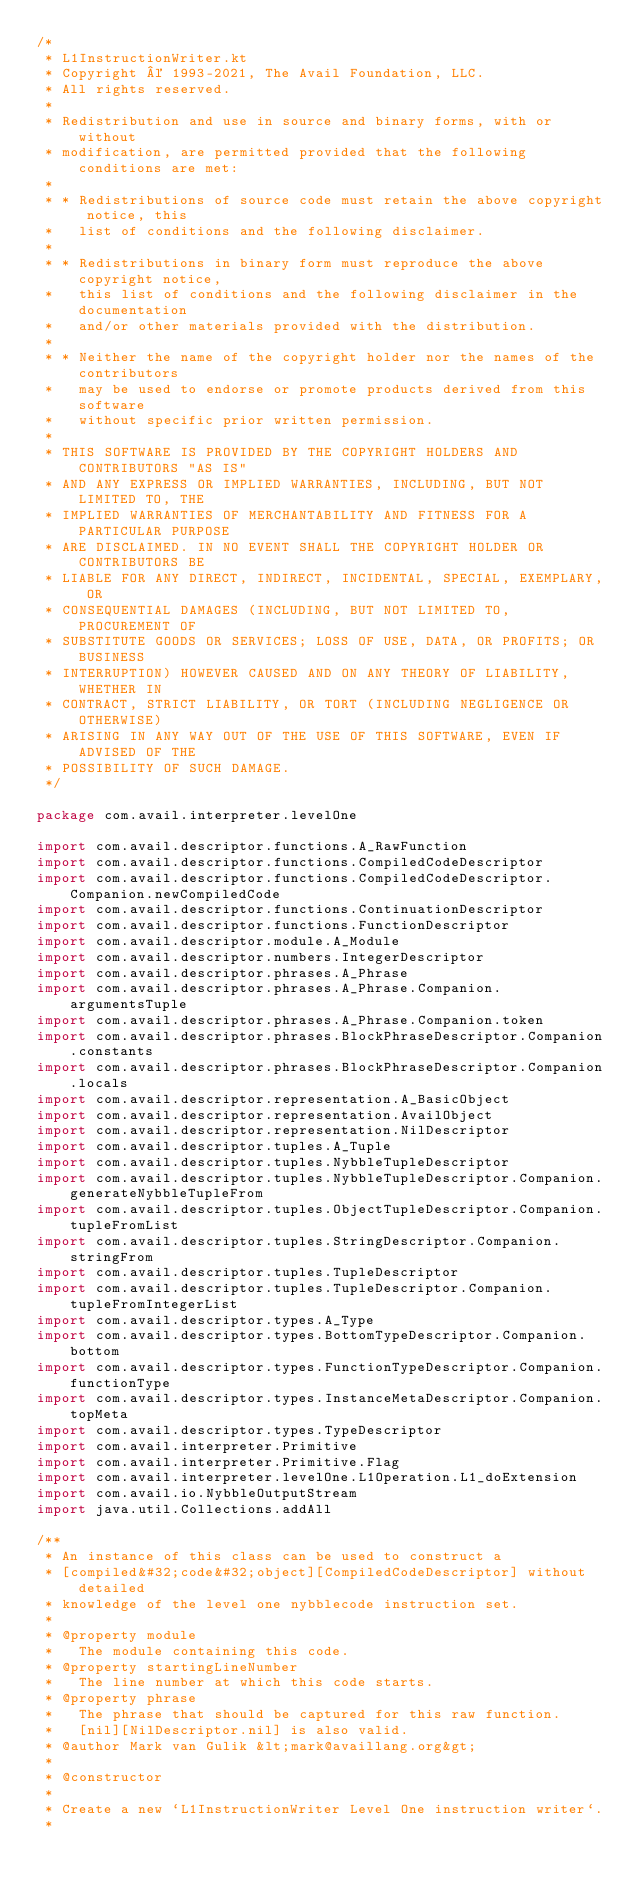<code> <loc_0><loc_0><loc_500><loc_500><_Kotlin_>/*
 * L1InstructionWriter.kt
 * Copyright © 1993-2021, The Avail Foundation, LLC.
 * All rights reserved.
 *
 * Redistribution and use in source and binary forms, with or without
 * modification, are permitted provided that the following conditions are met:
 *
 * * Redistributions of source code must retain the above copyright notice, this
 *   list of conditions and the following disclaimer.
 *
 * * Redistributions in binary form must reproduce the above copyright notice,
 *   this list of conditions and the following disclaimer in the documentation
 *   and/or other materials provided with the distribution.
 *
 * * Neither the name of the copyright holder nor the names of the contributors
 *   may be used to endorse or promote products derived from this software
 *   without specific prior written permission.
 *
 * THIS SOFTWARE IS PROVIDED BY THE COPYRIGHT HOLDERS AND CONTRIBUTORS "AS IS"
 * AND ANY EXPRESS OR IMPLIED WARRANTIES, INCLUDING, BUT NOT LIMITED TO, THE
 * IMPLIED WARRANTIES OF MERCHANTABILITY AND FITNESS FOR A PARTICULAR PURPOSE
 * ARE DISCLAIMED. IN NO EVENT SHALL THE COPYRIGHT HOLDER OR CONTRIBUTORS BE
 * LIABLE FOR ANY DIRECT, INDIRECT, INCIDENTAL, SPECIAL, EXEMPLARY, OR
 * CONSEQUENTIAL DAMAGES (INCLUDING, BUT NOT LIMITED TO, PROCUREMENT OF
 * SUBSTITUTE GOODS OR SERVICES; LOSS OF USE, DATA, OR PROFITS; OR BUSINESS
 * INTERRUPTION) HOWEVER CAUSED AND ON ANY THEORY OF LIABILITY, WHETHER IN
 * CONTRACT, STRICT LIABILITY, OR TORT (INCLUDING NEGLIGENCE OR OTHERWISE)
 * ARISING IN ANY WAY OUT OF THE USE OF THIS SOFTWARE, EVEN IF ADVISED OF THE
 * POSSIBILITY OF SUCH DAMAGE.
 */

package com.avail.interpreter.levelOne

import com.avail.descriptor.functions.A_RawFunction
import com.avail.descriptor.functions.CompiledCodeDescriptor
import com.avail.descriptor.functions.CompiledCodeDescriptor.Companion.newCompiledCode
import com.avail.descriptor.functions.ContinuationDescriptor
import com.avail.descriptor.functions.FunctionDescriptor
import com.avail.descriptor.module.A_Module
import com.avail.descriptor.numbers.IntegerDescriptor
import com.avail.descriptor.phrases.A_Phrase
import com.avail.descriptor.phrases.A_Phrase.Companion.argumentsTuple
import com.avail.descriptor.phrases.A_Phrase.Companion.token
import com.avail.descriptor.phrases.BlockPhraseDescriptor.Companion.constants
import com.avail.descriptor.phrases.BlockPhraseDescriptor.Companion.locals
import com.avail.descriptor.representation.A_BasicObject
import com.avail.descriptor.representation.AvailObject
import com.avail.descriptor.representation.NilDescriptor
import com.avail.descriptor.tuples.A_Tuple
import com.avail.descriptor.tuples.NybbleTupleDescriptor
import com.avail.descriptor.tuples.NybbleTupleDescriptor.Companion.generateNybbleTupleFrom
import com.avail.descriptor.tuples.ObjectTupleDescriptor.Companion.tupleFromList
import com.avail.descriptor.tuples.StringDescriptor.Companion.stringFrom
import com.avail.descriptor.tuples.TupleDescriptor
import com.avail.descriptor.tuples.TupleDescriptor.Companion.tupleFromIntegerList
import com.avail.descriptor.types.A_Type
import com.avail.descriptor.types.BottomTypeDescriptor.Companion.bottom
import com.avail.descriptor.types.FunctionTypeDescriptor.Companion.functionType
import com.avail.descriptor.types.InstanceMetaDescriptor.Companion.topMeta
import com.avail.descriptor.types.TypeDescriptor
import com.avail.interpreter.Primitive
import com.avail.interpreter.Primitive.Flag
import com.avail.interpreter.levelOne.L1Operation.L1_doExtension
import com.avail.io.NybbleOutputStream
import java.util.Collections.addAll

/**
 * An instance of this class can be used to construct a
 * [compiled&#32;code&#32;object][CompiledCodeDescriptor] without detailed
 * knowledge of the level one nybblecode instruction set.
 *
 * @property module
 *   The module containing this code.
 * @property startingLineNumber
 *   The line number at which this code starts.
 * @property phrase
 *   The phrase that should be captured for this raw function.
 *   [nil][NilDescriptor.nil] is also valid.
 * @author Mark van Gulik &lt;mark@availlang.org&gt;
 *
 * @constructor
 *
 * Create a new `L1InstructionWriter Level One instruction writer`.
 *</code> 